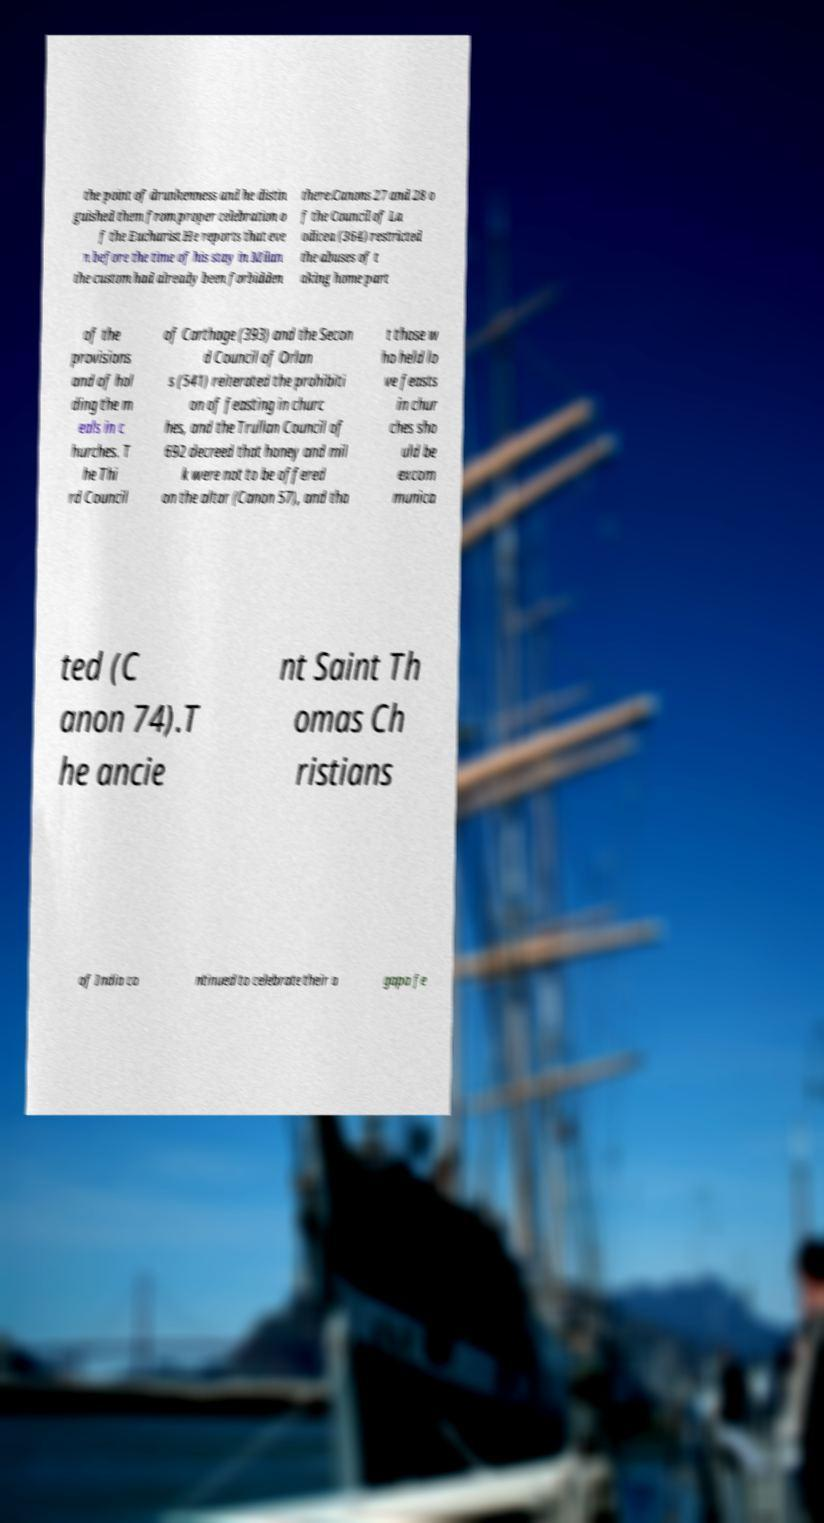There's text embedded in this image that I need extracted. Can you transcribe it verbatim? the point of drunkenness and he distin guished them from proper celebration o f the Eucharist He reports that eve n before the time of his stay in Milan the custom had already been forbidden there.Canons 27 and 28 o f the Council of La odicea (364) restricted the abuses of t aking home part of the provisions and of hol ding the m eals in c hurches. T he Thi rd Council of Carthage (393) and the Secon d Council of Orlan s (541) reiterated the prohibiti on of feasting in churc hes, and the Trullan Council of 692 decreed that honey and mil k were not to be offered on the altar (Canon 57), and tha t those w ho held lo ve feasts in chur ches sho uld be excom munica ted (C anon 74).T he ancie nt Saint Th omas Ch ristians of India co ntinued to celebrate their a gapa fe 